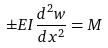<formula> <loc_0><loc_0><loc_500><loc_500>\pm E I \frac { d ^ { 2 } w } { d x ^ { 2 } } = M</formula> 